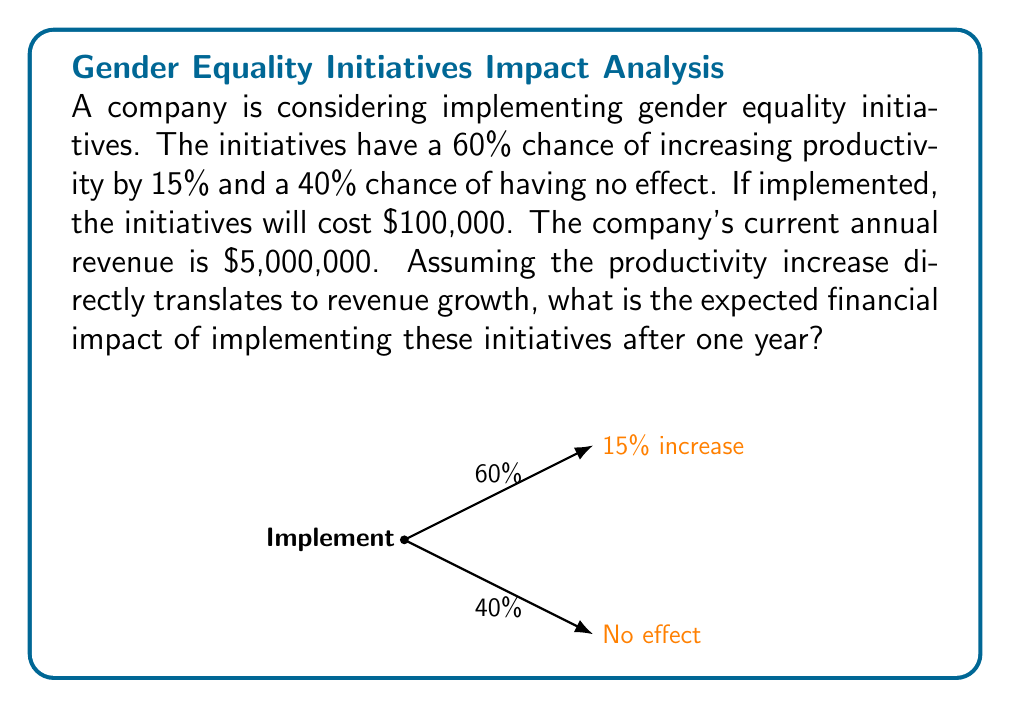Teach me how to tackle this problem. Let's approach this step-by-step:

1) First, we need to calculate the potential revenue increase if the initiatives are successful:
   
   15% of $5,000,000 = $5,000,000 * 0.15 = $750,000

2) Now, we can calculate the expected value of the revenue increase:
   
   $$E(\text{Revenue Increase}) = 0.60 * \$750,000 + 0.40 * \$0 = \$450,000$$

3) However, we need to subtract the cost of implementing the initiatives:
   
   $$\text{Net Impact} = E(\text{Revenue Increase}) - \text{Cost}$$
   $$\text{Net Impact} = \$450,000 - \$100,000 = \$350,000$$

4) Therefore, the expected financial impact after one year is $350,000.

This can be expressed mathematically as:

$$E(\text{Impact}) = (p * R * i) - C$$

Where:
$p$ = probability of success (0.60)
$R$ = current revenue ($5,000,000)
$i$ = expected increase (0.15)
$C$ = cost of implementation ($100,000)

$$E(\text{Impact}) = (0.60 * \$5,000,000 * 0.15) - \$100,000 = \$350,000$$
Answer: $350,000 